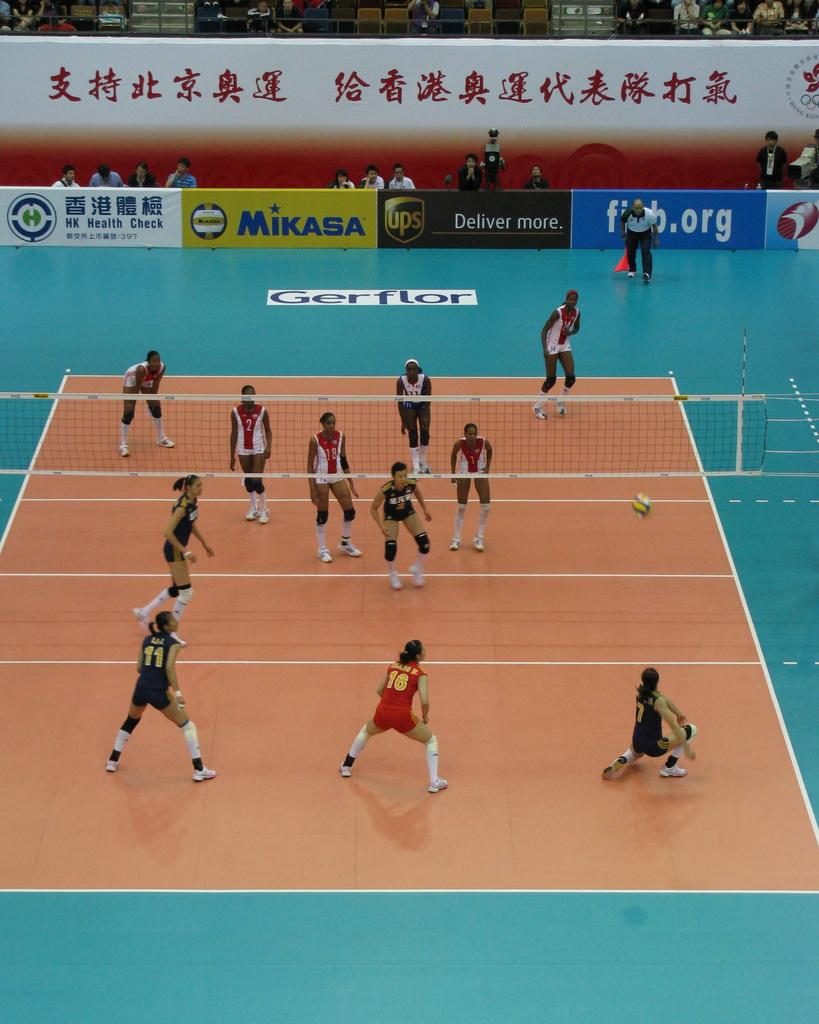<image>
Create a compact narrative representing the image presented. Two volleyball teams on a court surrounded by billboard advertisements for Mikasa and UPS 